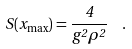<formula> <loc_0><loc_0><loc_500><loc_500>S ( x _ { \max } ) = \frac { 4 } { g ^ { 2 } \rho ^ { 2 } } \ \ .</formula> 